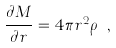Convert formula to latex. <formula><loc_0><loc_0><loc_500><loc_500>\frac { \partial M } { \partial r } = 4 \pi r ^ { 2 } \rho \ ,</formula> 